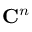Convert formula to latex. <formula><loc_0><loc_0><loc_500><loc_500>C ^ { n }</formula> 